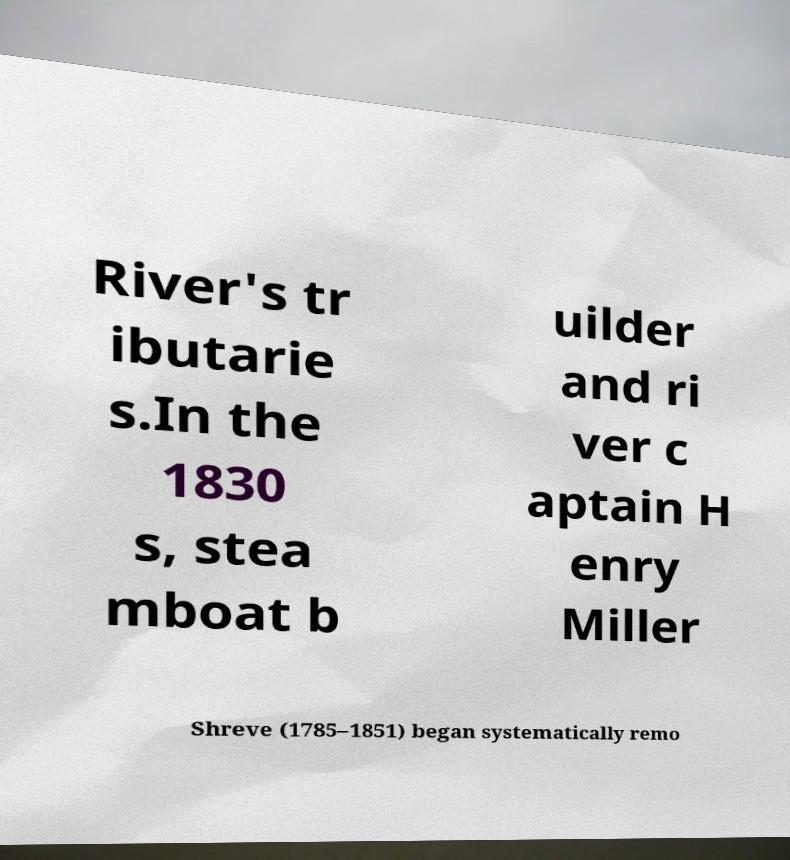Please identify and transcribe the text found in this image. River's tr ibutarie s.In the 1830 s, stea mboat b uilder and ri ver c aptain H enry Miller Shreve (1785–1851) began systematically remo 